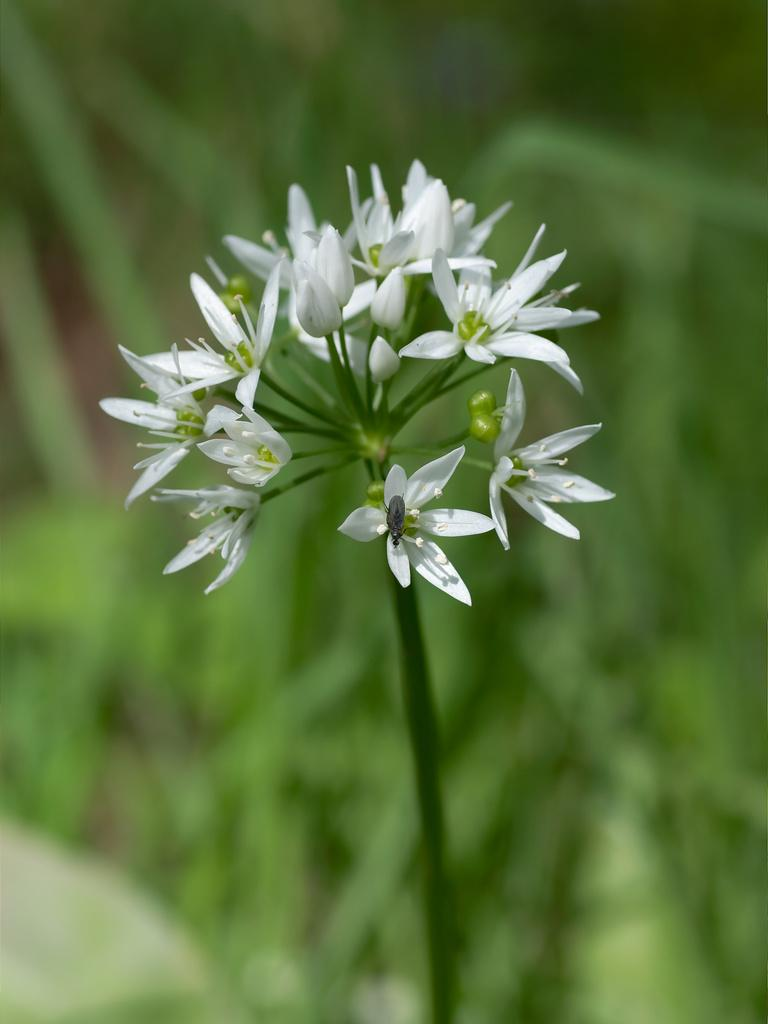What type of plant is visible in the image? There is a plant in the image with small white flowers. What additional features can be observed on the plant? The plant has buds. What can be seen in the background of the image? There are plants with green leaves in the background of the image. What type of pies is the farmer selling in the image? There is no farmer or pies present in the image; it features a plant with small white flowers and buds. 